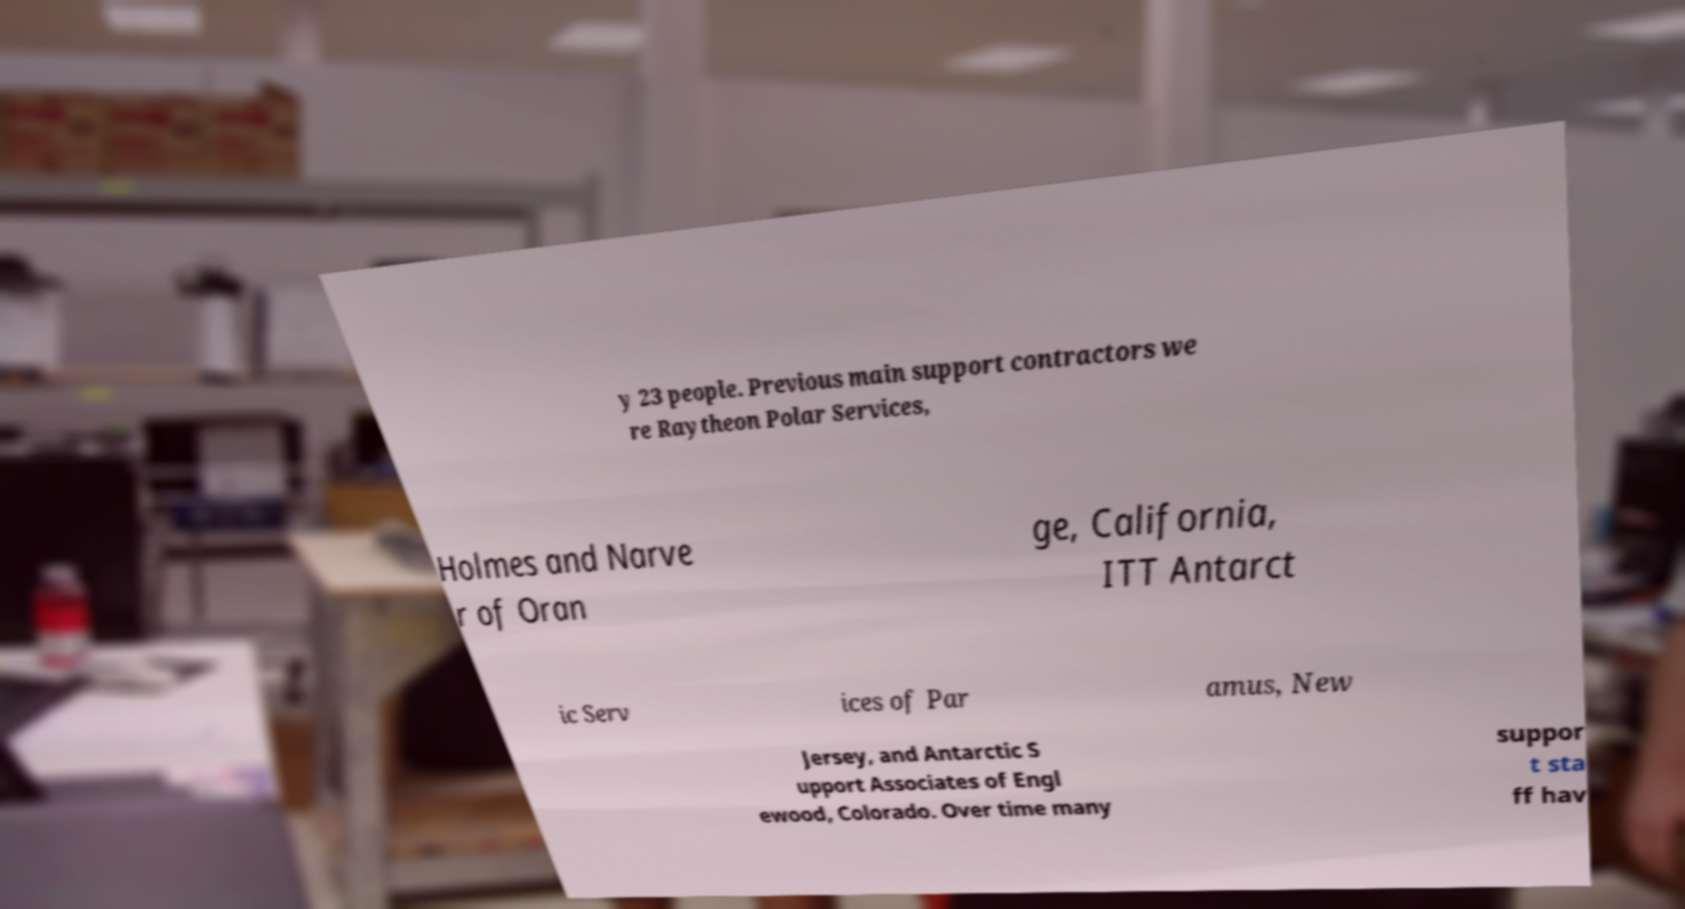Please read and relay the text visible in this image. What does it say? y 23 people. Previous main support contractors we re Raytheon Polar Services, Holmes and Narve r of Oran ge, California, ITT Antarct ic Serv ices of Par amus, New Jersey, and Antarctic S upport Associates of Engl ewood, Colorado. Over time many suppor t sta ff hav 